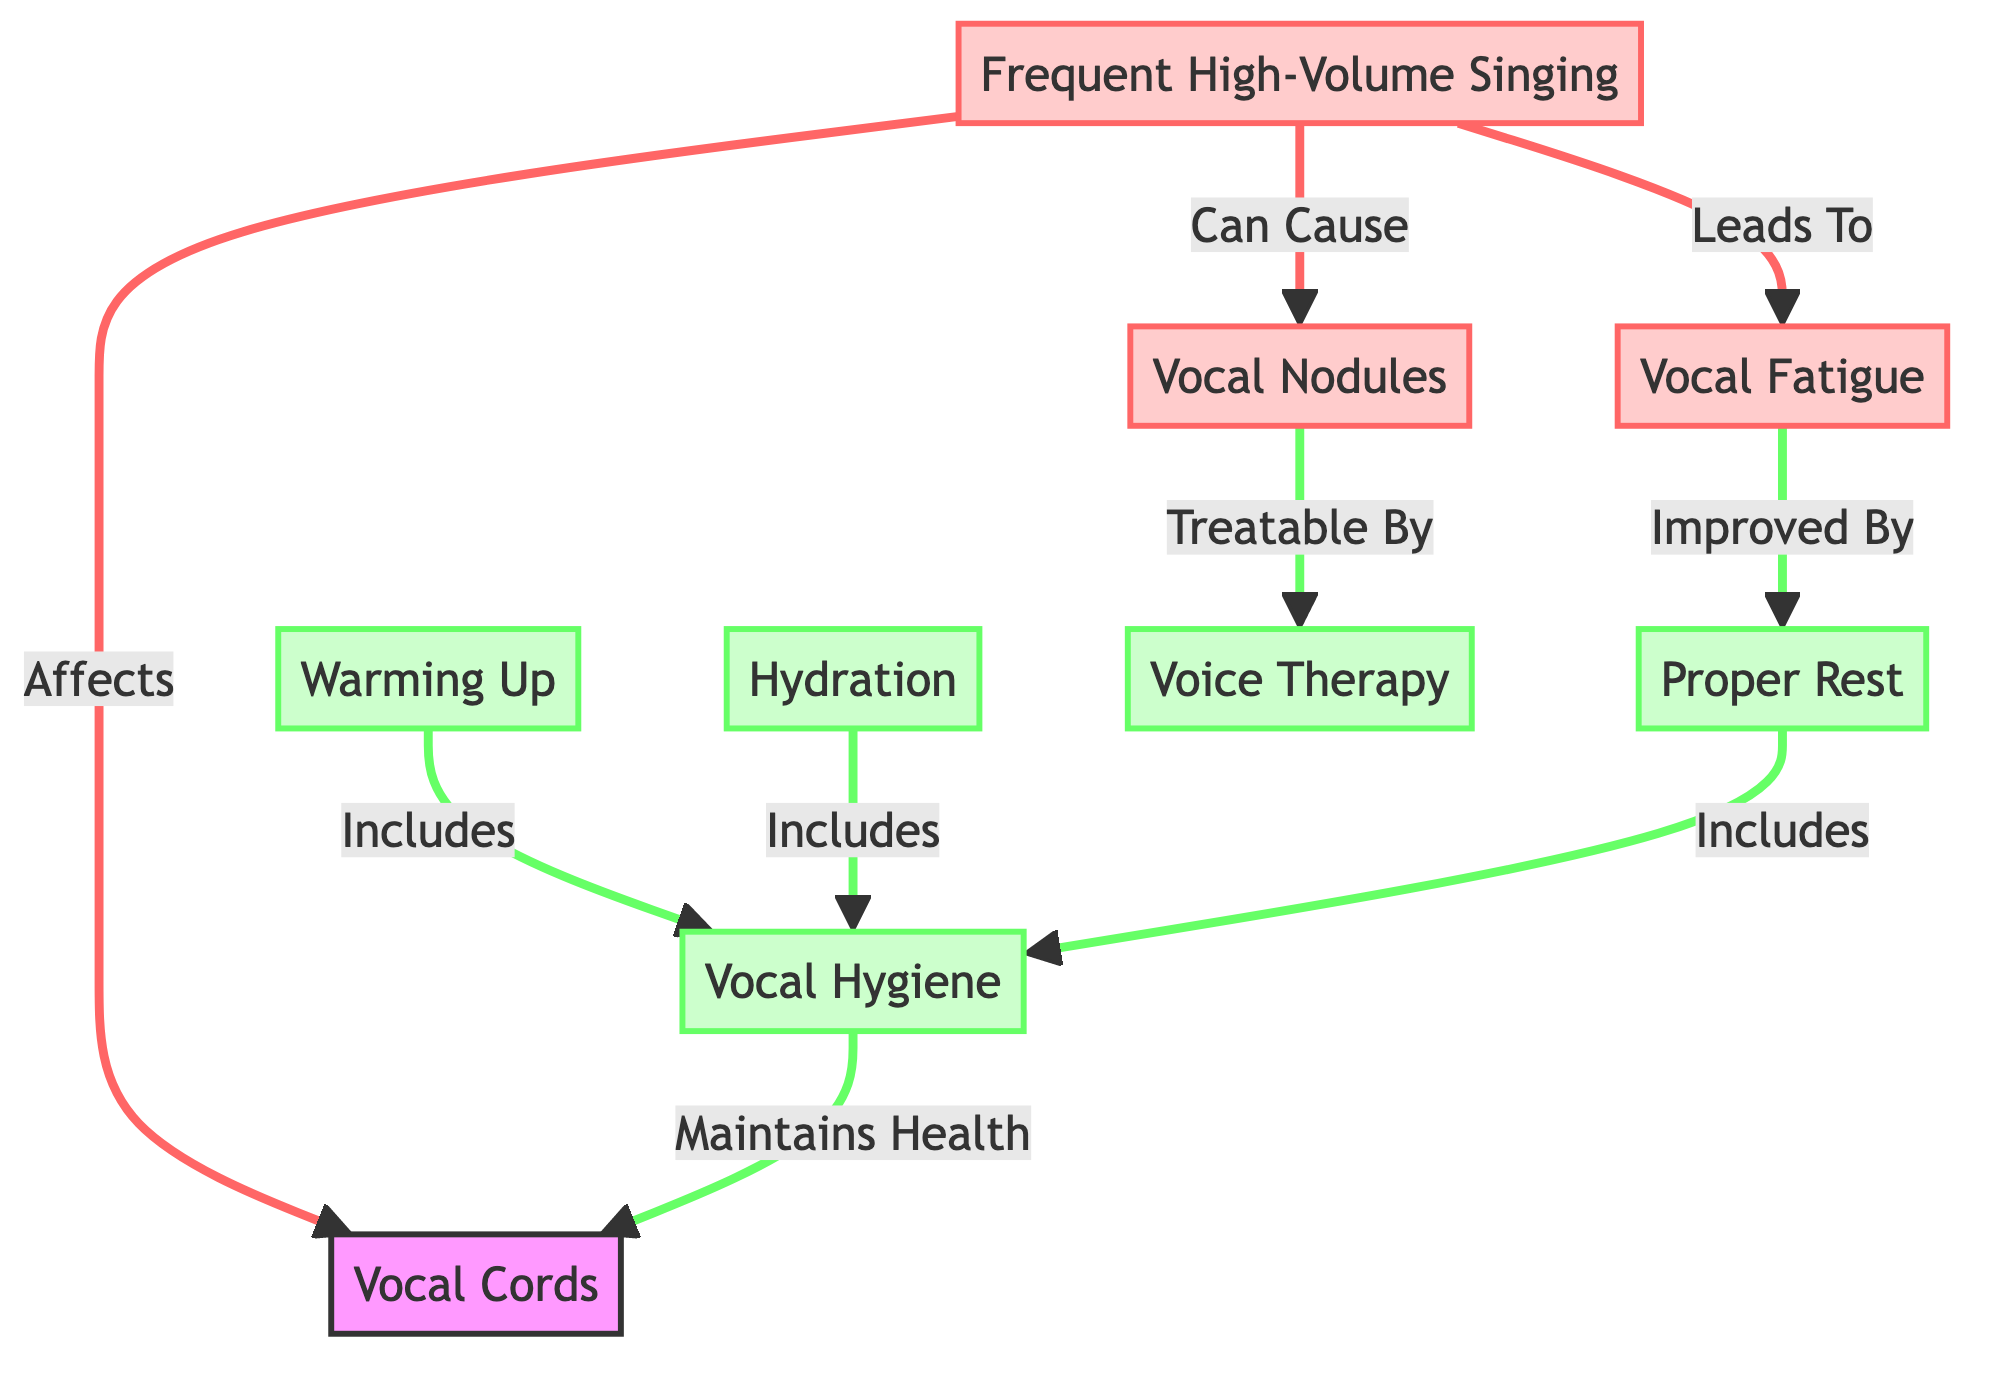What is the main component affected by frequent high-volume singing? According to the diagram, frequent high-volume singing directly affects the vocal cords, which is specified as the primary component.
Answer: Vocal Cords How many effects are caused by frequent high-volume singing? The diagram shows three effects: vocal nodules, vocal fatigue, and the direct impact on vocal cords, so the total count is three.
Answer: Three What maintains the health of the vocal cords? The diagram indicates that vocal hygiene is responsible for maintaining the health of the vocal cords.
Answer: Vocal Hygiene Which preventive measure includes vocal hygiene? Based on the diagram, warming up is identified as a preventive measure that includes vocal hygiene.
Answer: Warming Up What can improve vocal fatigue? The diagram specifies that proper rest can improve vocal fatigue, indicating a clear relationship between the two.
Answer: Proper Rest How are vocal nodules treated? The diagram illustrates that vocal nodules can be treated through voice therapy, establishing a direct treatment path.
Answer: Voice Therapy What leads to vocal fatigue? The diagram directly states that frequent high-volume singing leads to vocal fatigue, outlining a cause-effect relationship.
Answer: Vocal Fatigue What are the two major categories in the diagram? The diagram categorizes information into effects (vocal nodules and vocal fatigue) and preventive measures (vocal hygiene, warming up, hydration, rest, voice therapy), summarizing the main focus areas.
Answer: Effects and Preventive Measures How many preventive measures are listed in the diagram? Counting the nodes associated with preventive measures in the diagram, specifically: vocal hygiene, warming up, hydration, proper rest, and voice therapy, totals five preventive measures.
Answer: Five 